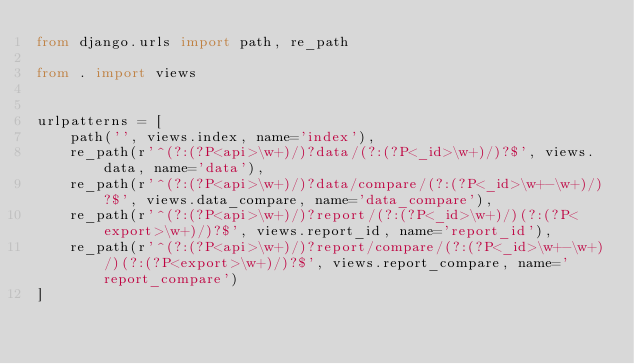Convert code to text. <code><loc_0><loc_0><loc_500><loc_500><_Python_>from django.urls import path, re_path

from . import views


urlpatterns = [
    path('', views.index, name='index'),
    re_path(r'^(?:(?P<api>\w+)/)?data/(?:(?P<_id>\w+)/)?$', views.data, name='data'),
    re_path(r'^(?:(?P<api>\w+)/)?data/compare/(?:(?P<_id>\w+-\w+)/)?$', views.data_compare, name='data_compare'),
    re_path(r'^(?:(?P<api>\w+)/)?report/(?:(?P<_id>\w+)/)(?:(?P<export>\w+)/)?$', views.report_id, name='report_id'),
    re_path(r'^(?:(?P<api>\w+)/)?report/compare/(?:(?P<_id>\w+-\w+)/)(?:(?P<export>\w+)/)?$', views.report_compare, name='report_compare')
]</code> 